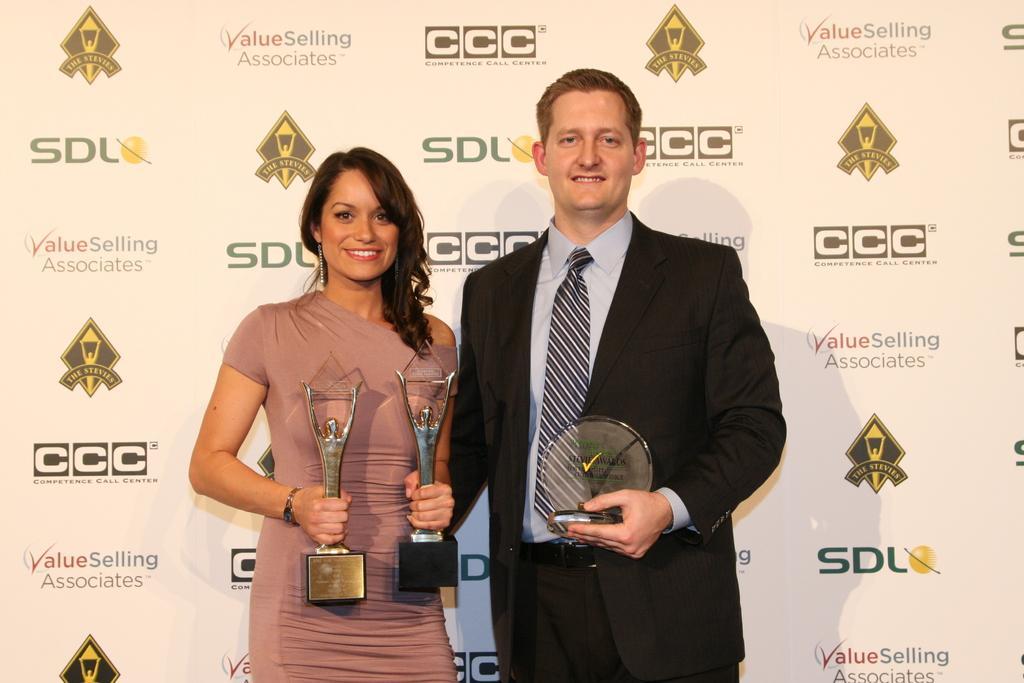Could you give a brief overview of what you see in this image? In this image, there are a few people holding some objects. In the background, we can see the board with some images and text. 